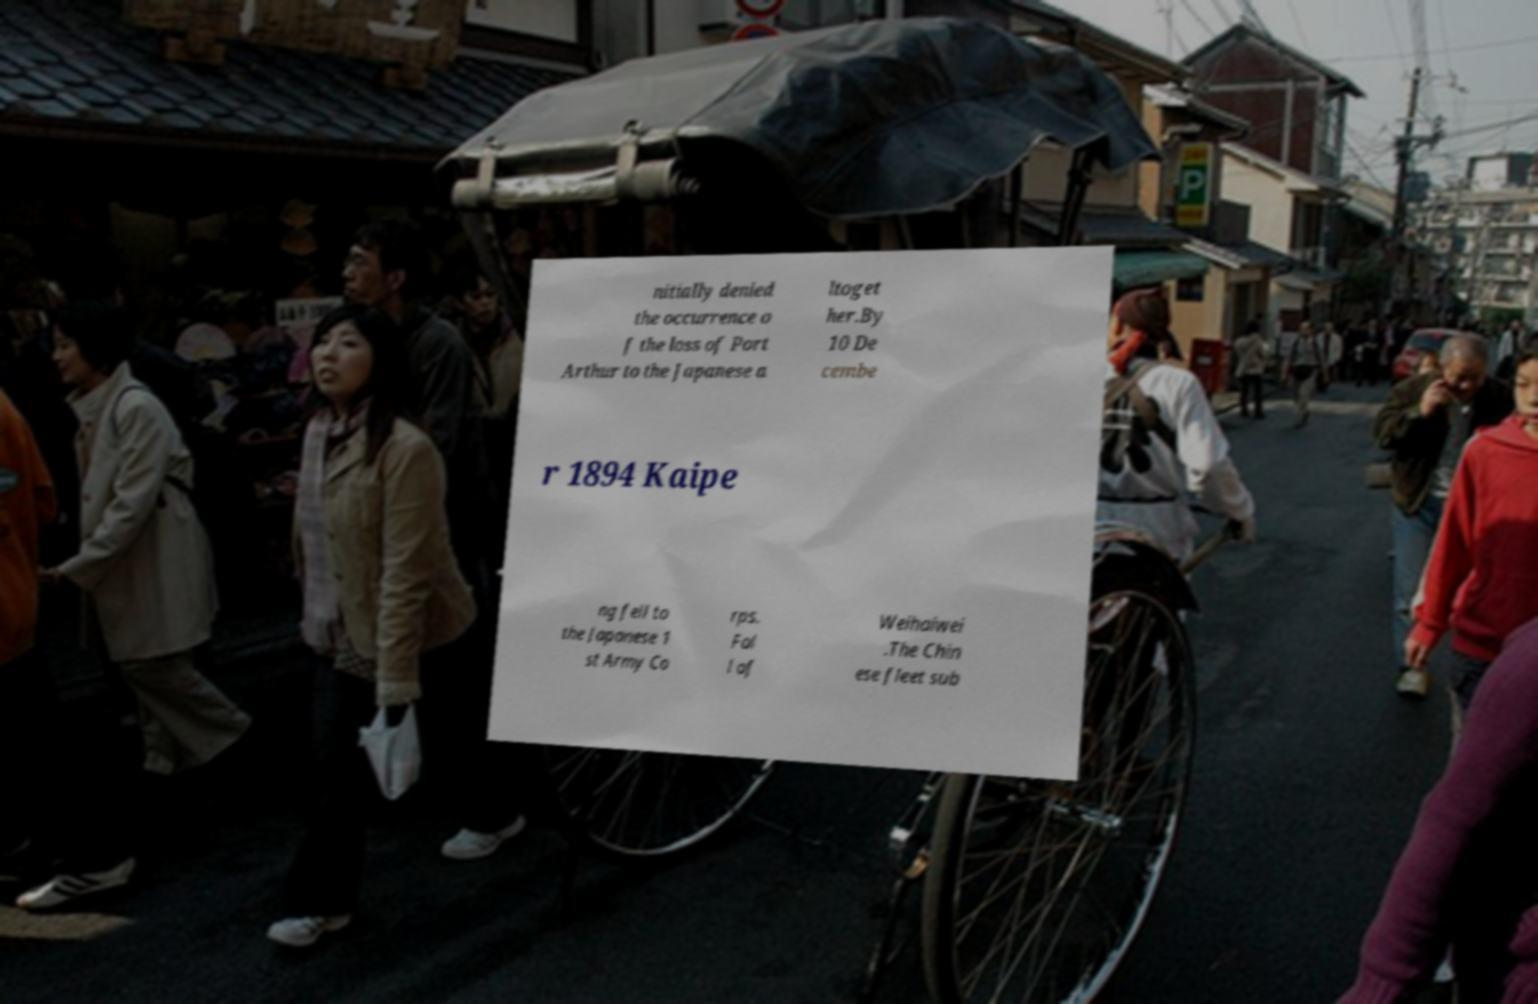Please identify and transcribe the text found in this image. nitially denied the occurrence o f the loss of Port Arthur to the Japanese a ltoget her.By 10 De cembe r 1894 Kaipe ng fell to the Japanese 1 st Army Co rps. Fal l of Weihaiwei .The Chin ese fleet sub 